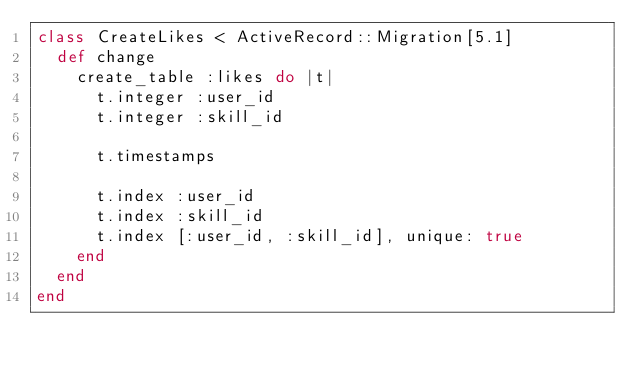Convert code to text. <code><loc_0><loc_0><loc_500><loc_500><_Ruby_>class CreateLikes < ActiveRecord::Migration[5.1]
  def change
    create_table :likes do |t|
      t.integer :user_id
      t.integer :skill_id

      t.timestamps

      t.index :user_id
      t.index :skill_id
      t.index [:user_id, :skill_id], unique: true
    end
  end
end
</code> 